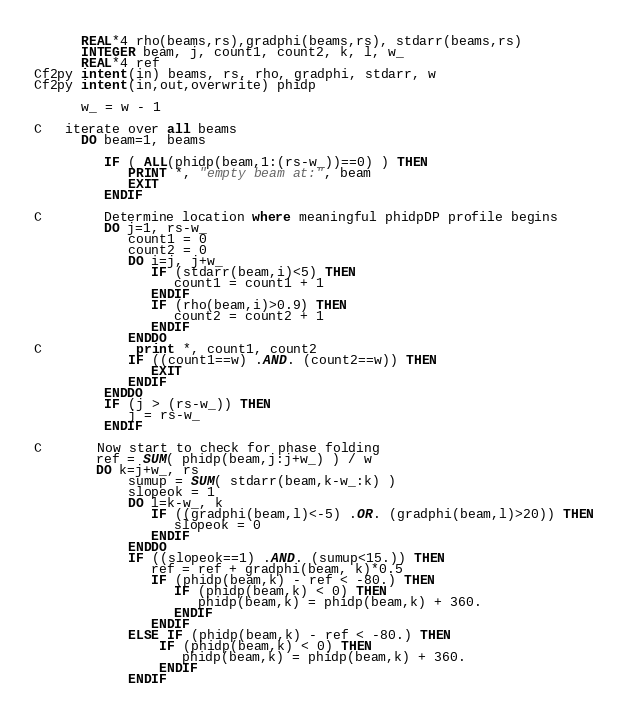<code> <loc_0><loc_0><loc_500><loc_500><_FORTRAN_>      REAL*4 rho(beams,rs),gradphi(beams,rs), stdarr(beams,rs)
      INTEGER beam, j, count1, count2, k, l, w_
      REAL*4 ref
Cf2py intent(in) beams, rs, rho, gradphi, stdarr, w
Cf2py intent(in,out,overwrite) phidp

      w_ = w - 1

C   iterate over all beams
      DO beam=1, beams
         
         IF ( ALL(phidp(beam,1:(rs-w_))==0) ) THEN
            PRINT *, "empty beam at:", beam
            EXIT
         ENDIF

C        Determine location where meaningful phidpDP profile begins
         DO j=1, rs-w_
            count1 = 0
            count2 = 0
            DO i=j, j+w_
               IF (stdarr(beam,i)<5) THEN
                  count1 = count1 + 1
               ENDIF
               IF (rho(beam,i)>0.9) THEN
                  count2 = count2 + 1
               ENDIF
            ENDDO
C            print *, count1, count2
            IF ((count1==w) .AND. (count2==w)) THEN
               EXIT
            ENDIF
         ENDDO
         IF (j > (rs-w_)) THEN
            j = rs-w_
         ENDIF

C       Now start to check for phase folding
        ref = SUM( phidp(beam,j:j+w_) ) / w
        DO k=j+w_, rs
            sumup = SUM( stdarr(beam,k-w_:k) )
            slopeok = 1
            DO l=k-w_, k
               IF ((gradphi(beam,l)<-5) .OR. (gradphi(beam,l)>20)) THEN
                  slopeok = 0
               ENDIF
            ENDDO
            IF ((slopeok==1) .AND. (sumup<15.)) THEN
               ref = ref + gradphi(beam, k)*0.5
               IF (phidp(beam,k) - ref < -80.) THEN
                  IF (phidp(beam,k) < 0) THEN
                     phidp(beam,k) = phidp(beam,k) + 360.
                  ENDIF
               ENDIF
            ELSE IF (phidp(beam,k) - ref < -80.) THEN
                IF (phidp(beam,k) < 0) THEN
                   phidp(beam,k) = phidp(beam,k) + 360.
                ENDIF
            ENDIF</code> 